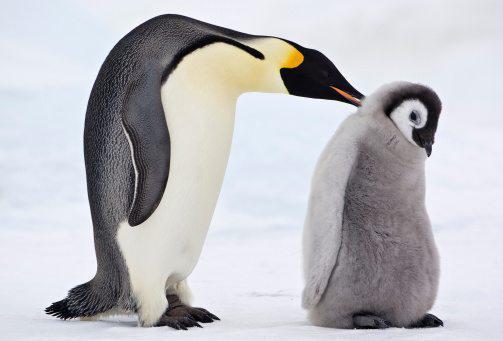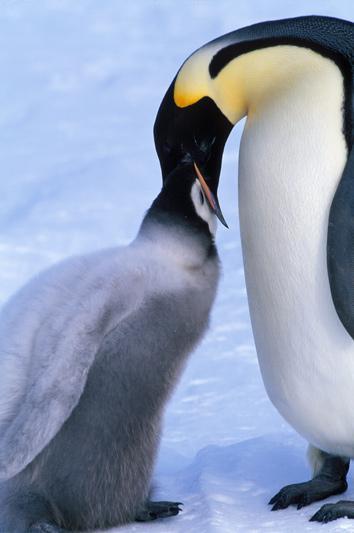The first image is the image on the left, the second image is the image on the right. For the images displayed, is the sentence "One penguin nuzzles another penguin in the back of the head." factually correct? Answer yes or no. Yes. The first image is the image on the left, the second image is the image on the right. Considering the images on both sides, is "One penguin is pushing a closed beak against the back of another penguin's head." valid? Answer yes or no. Yes. 